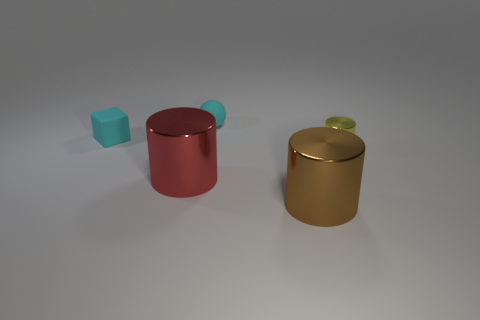Subtract all big cylinders. How many cylinders are left? 1 Add 4 small cyan matte things. How many objects exist? 9 Subtract all balls. How many objects are left? 4 Subtract all cyan cylinders. Subtract all gray blocks. How many cylinders are left? 3 Add 5 cylinders. How many cylinders exist? 8 Subtract 0 purple cylinders. How many objects are left? 5 Subtract all large green matte blocks. Subtract all cyan rubber things. How many objects are left? 3 Add 1 small shiny cylinders. How many small shiny cylinders are left? 2 